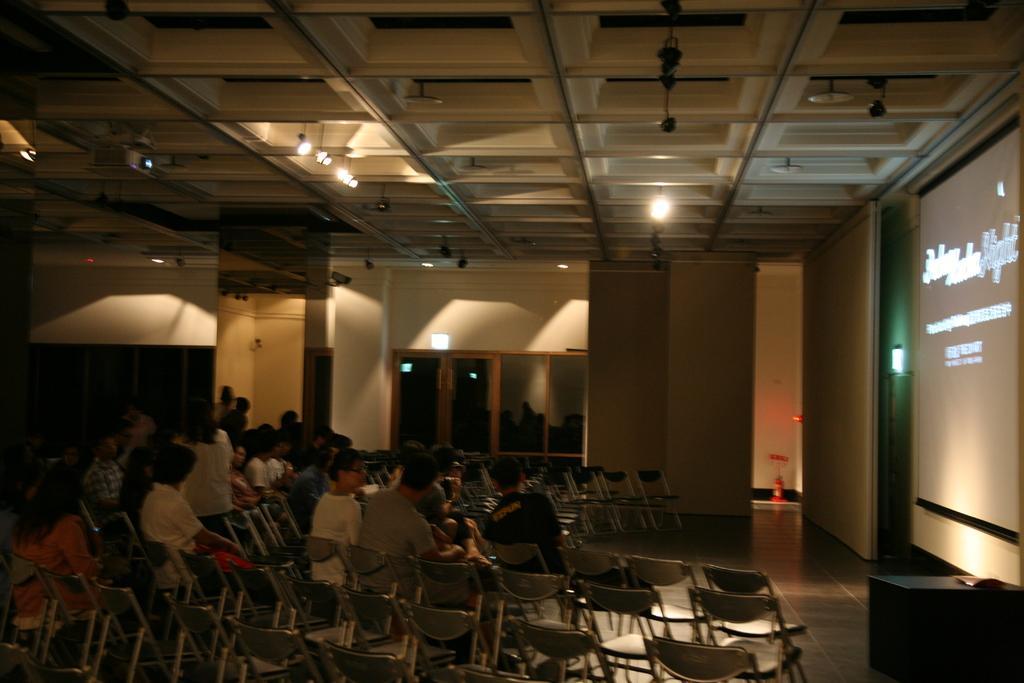How would you summarize this image in a sentence or two? In this image I can see the group of people sitting on the chairs and these people are in front of the screen 